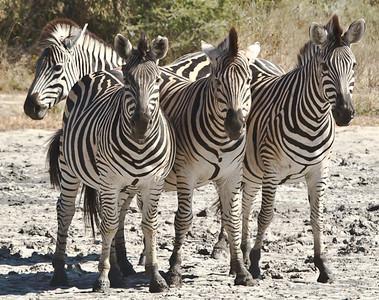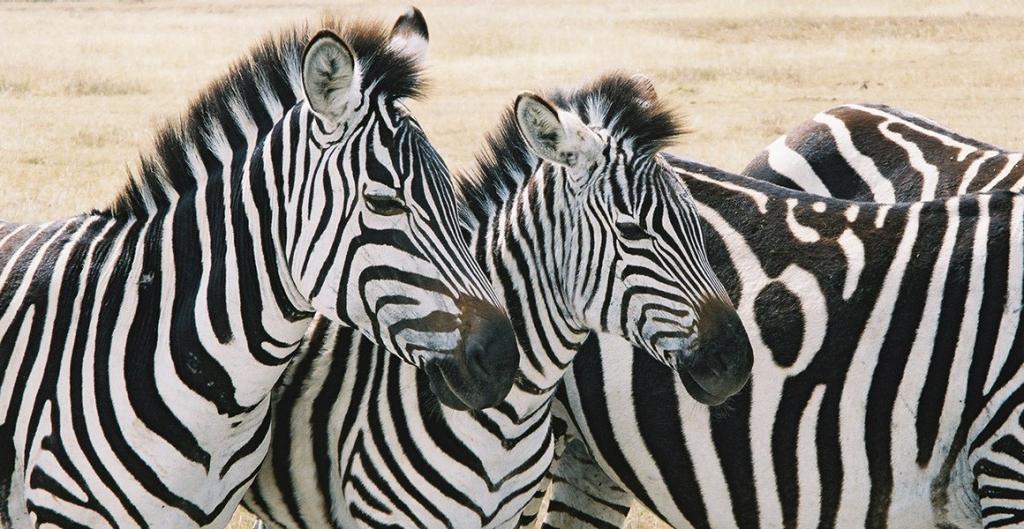The first image is the image on the left, the second image is the image on the right. Evaluate the accuracy of this statement regarding the images: "Each image contains three zebras in a neat row, and the zebras in the left and right images are in similar body poses but facing different directions.". Is it true? Answer yes or no. No. 